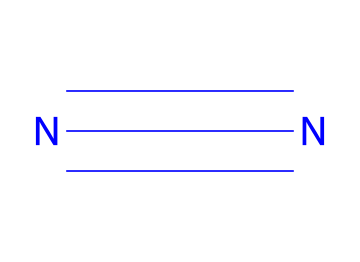What is the molecular formula of liquid nitrogen? The molecular structure provided is represented by N#N, which indicates that the molecule consists of two nitrogen atoms bonded by a triple bond. Thus, the molecular formula is N2.
Answer: N2 How many nitrogen atoms are in liquid nitrogen? Analyzing the SMILES representation N#N, we can identify that there are two nitrogen atoms.
Answer: 2 What type of bond is present in liquid nitrogen? The SMILES notation N#N indicates that there is a triple bond (denoted by the '#' symbol) between the two nitrogen atoms.
Answer: triple bond What is the shape of a liquid nitrogen molecule? In a molecule with two identical atoms connected by a triple bond, such as in N#N, the shape is linear due to the arrangement of the atoms and the bond type.
Answer: linear Why does liquid nitrogen have a low boiling point? Liquid nitrogen is composed of diatomic nitrogen (N2), which has weak van der Waals forces between the molecules, leading to a low boiling point. The linear geometry and nonpolarity of N2 contribute to this weakness.
Answer: weak forces Is liquid nitrogen a polar or nonpolar molecule? The structure N#N indicates that the molecule is symmetric and consists of identical atoms, which means it does not have any dipole moment; thus, it is nonpolar.
Answer: nonpolar What is a common use of liquid nitrogen? Liquid nitrogen is widely used for cryogenic freezing. Its extremely low temperature is effective for preserving biological samples and food items.
Answer: cryogenic freezing 